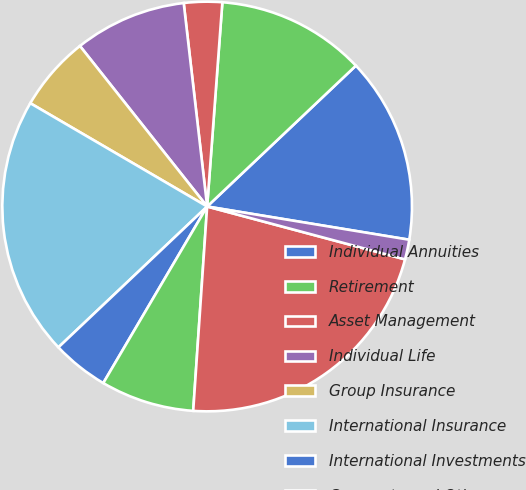Convert chart. <chart><loc_0><loc_0><loc_500><loc_500><pie_chart><fcel>Individual Annuities<fcel>Retirement<fcel>Asset Management<fcel>Individual Life<fcel>Group Insurance<fcel>International Insurance<fcel>International Investments<fcel>Corporate and Other<fcel>Realized investment gains<fcel>Charges related to realized<nl><fcel>14.66%<fcel>11.75%<fcel>3.01%<fcel>8.84%<fcel>5.92%<fcel>20.48%<fcel>4.47%<fcel>7.38%<fcel>21.93%<fcel>1.56%<nl></chart> 